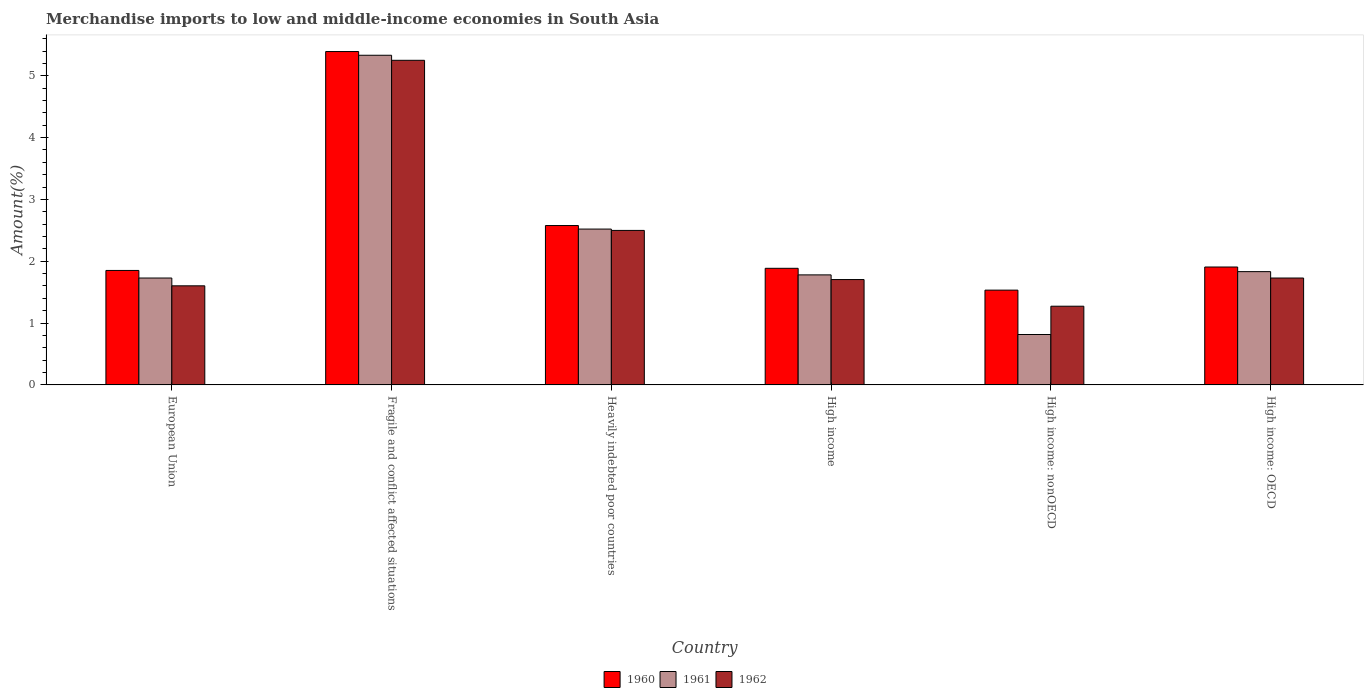How many groups of bars are there?
Your answer should be compact. 6. Are the number of bars per tick equal to the number of legend labels?
Your answer should be very brief. Yes. How many bars are there on the 6th tick from the right?
Make the answer very short. 3. What is the percentage of amount earned from merchandise imports in 1960 in High income: nonOECD?
Offer a very short reply. 1.53. Across all countries, what is the maximum percentage of amount earned from merchandise imports in 1960?
Your answer should be very brief. 5.39. Across all countries, what is the minimum percentage of amount earned from merchandise imports in 1960?
Ensure brevity in your answer.  1.53. In which country was the percentage of amount earned from merchandise imports in 1961 maximum?
Your answer should be very brief. Fragile and conflict affected situations. In which country was the percentage of amount earned from merchandise imports in 1962 minimum?
Provide a succinct answer. High income: nonOECD. What is the total percentage of amount earned from merchandise imports in 1961 in the graph?
Offer a very short reply. 14.01. What is the difference between the percentage of amount earned from merchandise imports in 1962 in Fragile and conflict affected situations and that in High income?
Give a very brief answer. 3.55. What is the difference between the percentage of amount earned from merchandise imports in 1960 in High income: nonOECD and the percentage of amount earned from merchandise imports in 1961 in European Union?
Offer a terse response. -0.2. What is the average percentage of amount earned from merchandise imports in 1961 per country?
Provide a succinct answer. 2.33. What is the difference between the percentage of amount earned from merchandise imports of/in 1962 and percentage of amount earned from merchandise imports of/in 1961 in European Union?
Provide a succinct answer. -0.13. In how many countries, is the percentage of amount earned from merchandise imports in 1962 greater than 5.2 %?
Provide a short and direct response. 1. What is the ratio of the percentage of amount earned from merchandise imports in 1962 in Fragile and conflict affected situations to that in High income: nonOECD?
Provide a short and direct response. 4.12. Is the percentage of amount earned from merchandise imports in 1960 in High income less than that in High income: nonOECD?
Keep it short and to the point. No. What is the difference between the highest and the second highest percentage of amount earned from merchandise imports in 1962?
Your answer should be compact. -0.77. What is the difference between the highest and the lowest percentage of amount earned from merchandise imports in 1961?
Offer a very short reply. 4.52. In how many countries, is the percentage of amount earned from merchandise imports in 1962 greater than the average percentage of amount earned from merchandise imports in 1962 taken over all countries?
Ensure brevity in your answer.  2. What does the 1st bar from the left in Fragile and conflict affected situations represents?
Ensure brevity in your answer.  1960. Is it the case that in every country, the sum of the percentage of amount earned from merchandise imports in 1961 and percentage of amount earned from merchandise imports in 1962 is greater than the percentage of amount earned from merchandise imports in 1960?
Keep it short and to the point. Yes. How many bars are there?
Your answer should be very brief. 18. Are all the bars in the graph horizontal?
Provide a short and direct response. No. How many countries are there in the graph?
Ensure brevity in your answer.  6. What is the difference between two consecutive major ticks on the Y-axis?
Offer a very short reply. 1. How many legend labels are there?
Your answer should be compact. 3. How are the legend labels stacked?
Your answer should be very brief. Horizontal. What is the title of the graph?
Your answer should be compact. Merchandise imports to low and middle-income economies in South Asia. What is the label or title of the X-axis?
Your response must be concise. Country. What is the label or title of the Y-axis?
Offer a terse response. Amount(%). What is the Amount(%) in 1960 in European Union?
Provide a succinct answer. 1.85. What is the Amount(%) in 1961 in European Union?
Offer a very short reply. 1.73. What is the Amount(%) of 1962 in European Union?
Provide a succinct answer. 1.6. What is the Amount(%) of 1960 in Fragile and conflict affected situations?
Your response must be concise. 5.39. What is the Amount(%) in 1961 in Fragile and conflict affected situations?
Provide a short and direct response. 5.33. What is the Amount(%) in 1962 in Fragile and conflict affected situations?
Ensure brevity in your answer.  5.25. What is the Amount(%) of 1960 in Heavily indebted poor countries?
Your response must be concise. 2.58. What is the Amount(%) in 1961 in Heavily indebted poor countries?
Your answer should be very brief. 2.52. What is the Amount(%) in 1962 in Heavily indebted poor countries?
Provide a succinct answer. 2.5. What is the Amount(%) of 1960 in High income?
Provide a succinct answer. 1.89. What is the Amount(%) of 1961 in High income?
Make the answer very short. 1.78. What is the Amount(%) of 1962 in High income?
Ensure brevity in your answer.  1.7. What is the Amount(%) of 1960 in High income: nonOECD?
Make the answer very short. 1.53. What is the Amount(%) in 1961 in High income: nonOECD?
Your answer should be very brief. 0.82. What is the Amount(%) in 1962 in High income: nonOECD?
Keep it short and to the point. 1.27. What is the Amount(%) of 1960 in High income: OECD?
Provide a short and direct response. 1.91. What is the Amount(%) in 1961 in High income: OECD?
Give a very brief answer. 1.83. What is the Amount(%) in 1962 in High income: OECD?
Offer a terse response. 1.73. Across all countries, what is the maximum Amount(%) in 1960?
Ensure brevity in your answer.  5.39. Across all countries, what is the maximum Amount(%) of 1961?
Offer a terse response. 5.33. Across all countries, what is the maximum Amount(%) in 1962?
Your response must be concise. 5.25. Across all countries, what is the minimum Amount(%) of 1960?
Offer a terse response. 1.53. Across all countries, what is the minimum Amount(%) in 1961?
Offer a very short reply. 0.82. Across all countries, what is the minimum Amount(%) of 1962?
Keep it short and to the point. 1.27. What is the total Amount(%) in 1960 in the graph?
Your answer should be very brief. 15.15. What is the total Amount(%) in 1961 in the graph?
Keep it short and to the point. 14.01. What is the total Amount(%) in 1962 in the graph?
Your response must be concise. 14.06. What is the difference between the Amount(%) of 1960 in European Union and that in Fragile and conflict affected situations?
Give a very brief answer. -3.54. What is the difference between the Amount(%) in 1961 in European Union and that in Fragile and conflict affected situations?
Provide a succinct answer. -3.6. What is the difference between the Amount(%) of 1962 in European Union and that in Fragile and conflict affected situations?
Give a very brief answer. -3.65. What is the difference between the Amount(%) of 1960 in European Union and that in Heavily indebted poor countries?
Keep it short and to the point. -0.73. What is the difference between the Amount(%) in 1961 in European Union and that in Heavily indebted poor countries?
Provide a succinct answer. -0.79. What is the difference between the Amount(%) in 1962 in European Union and that in Heavily indebted poor countries?
Make the answer very short. -0.9. What is the difference between the Amount(%) of 1960 in European Union and that in High income?
Your response must be concise. -0.03. What is the difference between the Amount(%) of 1961 in European Union and that in High income?
Offer a terse response. -0.05. What is the difference between the Amount(%) of 1962 in European Union and that in High income?
Offer a terse response. -0.1. What is the difference between the Amount(%) in 1960 in European Union and that in High income: nonOECD?
Keep it short and to the point. 0.32. What is the difference between the Amount(%) in 1961 in European Union and that in High income: nonOECD?
Your response must be concise. 0.91. What is the difference between the Amount(%) of 1962 in European Union and that in High income: nonOECD?
Keep it short and to the point. 0.33. What is the difference between the Amount(%) of 1960 in European Union and that in High income: OECD?
Provide a short and direct response. -0.06. What is the difference between the Amount(%) in 1961 in European Union and that in High income: OECD?
Provide a short and direct response. -0.1. What is the difference between the Amount(%) of 1962 in European Union and that in High income: OECD?
Your response must be concise. -0.13. What is the difference between the Amount(%) of 1960 in Fragile and conflict affected situations and that in Heavily indebted poor countries?
Your answer should be compact. 2.81. What is the difference between the Amount(%) of 1961 in Fragile and conflict affected situations and that in Heavily indebted poor countries?
Offer a very short reply. 2.81. What is the difference between the Amount(%) of 1962 in Fragile and conflict affected situations and that in Heavily indebted poor countries?
Ensure brevity in your answer.  2.75. What is the difference between the Amount(%) of 1960 in Fragile and conflict affected situations and that in High income?
Make the answer very short. 3.51. What is the difference between the Amount(%) of 1961 in Fragile and conflict affected situations and that in High income?
Your answer should be very brief. 3.55. What is the difference between the Amount(%) of 1962 in Fragile and conflict affected situations and that in High income?
Make the answer very short. 3.55. What is the difference between the Amount(%) of 1960 in Fragile and conflict affected situations and that in High income: nonOECD?
Provide a short and direct response. 3.86. What is the difference between the Amount(%) of 1961 in Fragile and conflict affected situations and that in High income: nonOECD?
Give a very brief answer. 4.52. What is the difference between the Amount(%) of 1962 in Fragile and conflict affected situations and that in High income: nonOECD?
Offer a very short reply. 3.98. What is the difference between the Amount(%) in 1960 in Fragile and conflict affected situations and that in High income: OECD?
Your answer should be compact. 3.49. What is the difference between the Amount(%) of 1961 in Fragile and conflict affected situations and that in High income: OECD?
Give a very brief answer. 3.5. What is the difference between the Amount(%) in 1962 in Fragile and conflict affected situations and that in High income: OECD?
Offer a very short reply. 3.52. What is the difference between the Amount(%) in 1960 in Heavily indebted poor countries and that in High income?
Provide a short and direct response. 0.69. What is the difference between the Amount(%) in 1961 in Heavily indebted poor countries and that in High income?
Your answer should be very brief. 0.74. What is the difference between the Amount(%) in 1962 in Heavily indebted poor countries and that in High income?
Offer a very short reply. 0.79. What is the difference between the Amount(%) in 1960 in Heavily indebted poor countries and that in High income: nonOECD?
Make the answer very short. 1.04. What is the difference between the Amount(%) in 1961 in Heavily indebted poor countries and that in High income: nonOECD?
Your answer should be very brief. 1.71. What is the difference between the Amount(%) in 1962 in Heavily indebted poor countries and that in High income: nonOECD?
Keep it short and to the point. 1.23. What is the difference between the Amount(%) in 1960 in Heavily indebted poor countries and that in High income: OECD?
Keep it short and to the point. 0.67. What is the difference between the Amount(%) in 1961 in Heavily indebted poor countries and that in High income: OECD?
Provide a succinct answer. 0.69. What is the difference between the Amount(%) of 1962 in Heavily indebted poor countries and that in High income: OECD?
Make the answer very short. 0.77. What is the difference between the Amount(%) of 1960 in High income and that in High income: nonOECD?
Provide a short and direct response. 0.35. What is the difference between the Amount(%) in 1961 in High income and that in High income: nonOECD?
Give a very brief answer. 0.96. What is the difference between the Amount(%) of 1962 in High income and that in High income: nonOECD?
Provide a short and direct response. 0.43. What is the difference between the Amount(%) in 1960 in High income and that in High income: OECD?
Keep it short and to the point. -0.02. What is the difference between the Amount(%) of 1961 in High income and that in High income: OECD?
Give a very brief answer. -0.05. What is the difference between the Amount(%) of 1962 in High income and that in High income: OECD?
Make the answer very short. -0.02. What is the difference between the Amount(%) in 1960 in High income: nonOECD and that in High income: OECD?
Provide a short and direct response. -0.37. What is the difference between the Amount(%) of 1961 in High income: nonOECD and that in High income: OECD?
Provide a short and direct response. -1.02. What is the difference between the Amount(%) of 1962 in High income: nonOECD and that in High income: OECD?
Ensure brevity in your answer.  -0.46. What is the difference between the Amount(%) in 1960 in European Union and the Amount(%) in 1961 in Fragile and conflict affected situations?
Make the answer very short. -3.48. What is the difference between the Amount(%) of 1960 in European Union and the Amount(%) of 1962 in Fragile and conflict affected situations?
Provide a short and direct response. -3.4. What is the difference between the Amount(%) of 1961 in European Union and the Amount(%) of 1962 in Fragile and conflict affected situations?
Make the answer very short. -3.52. What is the difference between the Amount(%) in 1960 in European Union and the Amount(%) in 1961 in Heavily indebted poor countries?
Provide a succinct answer. -0.67. What is the difference between the Amount(%) in 1960 in European Union and the Amount(%) in 1962 in Heavily indebted poor countries?
Offer a very short reply. -0.65. What is the difference between the Amount(%) in 1961 in European Union and the Amount(%) in 1962 in Heavily indebted poor countries?
Your response must be concise. -0.77. What is the difference between the Amount(%) of 1960 in European Union and the Amount(%) of 1961 in High income?
Ensure brevity in your answer.  0.07. What is the difference between the Amount(%) in 1960 in European Union and the Amount(%) in 1962 in High income?
Make the answer very short. 0.15. What is the difference between the Amount(%) in 1961 in European Union and the Amount(%) in 1962 in High income?
Offer a terse response. 0.02. What is the difference between the Amount(%) in 1960 in European Union and the Amount(%) in 1961 in High income: nonOECD?
Offer a very short reply. 1.04. What is the difference between the Amount(%) in 1960 in European Union and the Amount(%) in 1962 in High income: nonOECD?
Give a very brief answer. 0.58. What is the difference between the Amount(%) in 1961 in European Union and the Amount(%) in 1962 in High income: nonOECD?
Make the answer very short. 0.46. What is the difference between the Amount(%) of 1960 in European Union and the Amount(%) of 1961 in High income: OECD?
Give a very brief answer. 0.02. What is the difference between the Amount(%) in 1960 in European Union and the Amount(%) in 1962 in High income: OECD?
Your answer should be compact. 0.12. What is the difference between the Amount(%) of 1960 in Fragile and conflict affected situations and the Amount(%) of 1961 in Heavily indebted poor countries?
Make the answer very short. 2.87. What is the difference between the Amount(%) in 1960 in Fragile and conflict affected situations and the Amount(%) in 1962 in Heavily indebted poor countries?
Provide a short and direct response. 2.89. What is the difference between the Amount(%) of 1961 in Fragile and conflict affected situations and the Amount(%) of 1962 in Heavily indebted poor countries?
Offer a very short reply. 2.83. What is the difference between the Amount(%) of 1960 in Fragile and conflict affected situations and the Amount(%) of 1961 in High income?
Ensure brevity in your answer.  3.61. What is the difference between the Amount(%) in 1960 in Fragile and conflict affected situations and the Amount(%) in 1962 in High income?
Your answer should be very brief. 3.69. What is the difference between the Amount(%) of 1961 in Fragile and conflict affected situations and the Amount(%) of 1962 in High income?
Your answer should be compact. 3.63. What is the difference between the Amount(%) of 1960 in Fragile and conflict affected situations and the Amount(%) of 1961 in High income: nonOECD?
Your response must be concise. 4.58. What is the difference between the Amount(%) in 1960 in Fragile and conflict affected situations and the Amount(%) in 1962 in High income: nonOECD?
Give a very brief answer. 4.12. What is the difference between the Amount(%) in 1961 in Fragile and conflict affected situations and the Amount(%) in 1962 in High income: nonOECD?
Your response must be concise. 4.06. What is the difference between the Amount(%) in 1960 in Fragile and conflict affected situations and the Amount(%) in 1961 in High income: OECD?
Make the answer very short. 3.56. What is the difference between the Amount(%) in 1960 in Fragile and conflict affected situations and the Amount(%) in 1962 in High income: OECD?
Your answer should be compact. 3.66. What is the difference between the Amount(%) of 1961 in Fragile and conflict affected situations and the Amount(%) of 1962 in High income: OECD?
Make the answer very short. 3.6. What is the difference between the Amount(%) of 1960 in Heavily indebted poor countries and the Amount(%) of 1961 in High income?
Your answer should be very brief. 0.8. What is the difference between the Amount(%) in 1960 in Heavily indebted poor countries and the Amount(%) in 1962 in High income?
Provide a short and direct response. 0.87. What is the difference between the Amount(%) of 1961 in Heavily indebted poor countries and the Amount(%) of 1962 in High income?
Keep it short and to the point. 0.82. What is the difference between the Amount(%) in 1960 in Heavily indebted poor countries and the Amount(%) in 1961 in High income: nonOECD?
Offer a very short reply. 1.76. What is the difference between the Amount(%) of 1960 in Heavily indebted poor countries and the Amount(%) of 1962 in High income: nonOECD?
Offer a very short reply. 1.3. What is the difference between the Amount(%) of 1961 in Heavily indebted poor countries and the Amount(%) of 1962 in High income: nonOECD?
Your answer should be very brief. 1.25. What is the difference between the Amount(%) in 1960 in Heavily indebted poor countries and the Amount(%) in 1961 in High income: OECD?
Your response must be concise. 0.75. What is the difference between the Amount(%) of 1960 in Heavily indebted poor countries and the Amount(%) of 1962 in High income: OECD?
Keep it short and to the point. 0.85. What is the difference between the Amount(%) in 1961 in Heavily indebted poor countries and the Amount(%) in 1962 in High income: OECD?
Keep it short and to the point. 0.79. What is the difference between the Amount(%) of 1960 in High income and the Amount(%) of 1961 in High income: nonOECD?
Provide a succinct answer. 1.07. What is the difference between the Amount(%) of 1960 in High income and the Amount(%) of 1962 in High income: nonOECD?
Ensure brevity in your answer.  0.61. What is the difference between the Amount(%) in 1961 in High income and the Amount(%) in 1962 in High income: nonOECD?
Provide a succinct answer. 0.51. What is the difference between the Amount(%) in 1960 in High income and the Amount(%) in 1961 in High income: OECD?
Make the answer very short. 0.05. What is the difference between the Amount(%) in 1960 in High income and the Amount(%) in 1962 in High income: OECD?
Give a very brief answer. 0.16. What is the difference between the Amount(%) of 1961 in High income and the Amount(%) of 1962 in High income: OECD?
Provide a succinct answer. 0.05. What is the difference between the Amount(%) in 1960 in High income: nonOECD and the Amount(%) in 1961 in High income: OECD?
Offer a very short reply. -0.3. What is the difference between the Amount(%) of 1960 in High income: nonOECD and the Amount(%) of 1962 in High income: OECD?
Your answer should be very brief. -0.2. What is the difference between the Amount(%) in 1961 in High income: nonOECD and the Amount(%) in 1962 in High income: OECD?
Your answer should be very brief. -0.91. What is the average Amount(%) in 1960 per country?
Provide a short and direct response. 2.52. What is the average Amount(%) in 1961 per country?
Keep it short and to the point. 2.33. What is the average Amount(%) of 1962 per country?
Offer a very short reply. 2.34. What is the difference between the Amount(%) of 1960 and Amount(%) of 1961 in European Union?
Provide a succinct answer. 0.12. What is the difference between the Amount(%) in 1960 and Amount(%) in 1962 in European Union?
Your answer should be compact. 0.25. What is the difference between the Amount(%) of 1961 and Amount(%) of 1962 in European Union?
Give a very brief answer. 0.13. What is the difference between the Amount(%) in 1960 and Amount(%) in 1961 in Fragile and conflict affected situations?
Provide a short and direct response. 0.06. What is the difference between the Amount(%) of 1960 and Amount(%) of 1962 in Fragile and conflict affected situations?
Make the answer very short. 0.14. What is the difference between the Amount(%) of 1961 and Amount(%) of 1962 in Fragile and conflict affected situations?
Give a very brief answer. 0.08. What is the difference between the Amount(%) of 1960 and Amount(%) of 1961 in Heavily indebted poor countries?
Ensure brevity in your answer.  0.06. What is the difference between the Amount(%) in 1960 and Amount(%) in 1962 in Heavily indebted poor countries?
Give a very brief answer. 0.08. What is the difference between the Amount(%) of 1961 and Amount(%) of 1962 in Heavily indebted poor countries?
Offer a very short reply. 0.02. What is the difference between the Amount(%) of 1960 and Amount(%) of 1961 in High income?
Provide a short and direct response. 0.11. What is the difference between the Amount(%) of 1960 and Amount(%) of 1962 in High income?
Provide a succinct answer. 0.18. What is the difference between the Amount(%) of 1961 and Amount(%) of 1962 in High income?
Provide a succinct answer. 0.08. What is the difference between the Amount(%) of 1960 and Amount(%) of 1961 in High income: nonOECD?
Provide a succinct answer. 0.72. What is the difference between the Amount(%) of 1960 and Amount(%) of 1962 in High income: nonOECD?
Make the answer very short. 0.26. What is the difference between the Amount(%) in 1961 and Amount(%) in 1962 in High income: nonOECD?
Provide a short and direct response. -0.46. What is the difference between the Amount(%) in 1960 and Amount(%) in 1961 in High income: OECD?
Your answer should be compact. 0.07. What is the difference between the Amount(%) of 1960 and Amount(%) of 1962 in High income: OECD?
Provide a succinct answer. 0.18. What is the difference between the Amount(%) in 1961 and Amount(%) in 1962 in High income: OECD?
Give a very brief answer. 0.1. What is the ratio of the Amount(%) in 1960 in European Union to that in Fragile and conflict affected situations?
Your answer should be very brief. 0.34. What is the ratio of the Amount(%) in 1961 in European Union to that in Fragile and conflict affected situations?
Provide a short and direct response. 0.32. What is the ratio of the Amount(%) of 1962 in European Union to that in Fragile and conflict affected situations?
Offer a terse response. 0.31. What is the ratio of the Amount(%) of 1960 in European Union to that in Heavily indebted poor countries?
Provide a short and direct response. 0.72. What is the ratio of the Amount(%) in 1961 in European Union to that in Heavily indebted poor countries?
Your answer should be very brief. 0.69. What is the ratio of the Amount(%) in 1962 in European Union to that in Heavily indebted poor countries?
Your response must be concise. 0.64. What is the ratio of the Amount(%) of 1960 in European Union to that in High income?
Give a very brief answer. 0.98. What is the ratio of the Amount(%) in 1961 in European Union to that in High income?
Your answer should be very brief. 0.97. What is the ratio of the Amount(%) in 1962 in European Union to that in High income?
Make the answer very short. 0.94. What is the ratio of the Amount(%) in 1960 in European Union to that in High income: nonOECD?
Make the answer very short. 1.21. What is the ratio of the Amount(%) in 1961 in European Union to that in High income: nonOECD?
Keep it short and to the point. 2.12. What is the ratio of the Amount(%) of 1962 in European Union to that in High income: nonOECD?
Your answer should be very brief. 1.26. What is the ratio of the Amount(%) in 1960 in European Union to that in High income: OECD?
Keep it short and to the point. 0.97. What is the ratio of the Amount(%) in 1961 in European Union to that in High income: OECD?
Offer a terse response. 0.94. What is the ratio of the Amount(%) of 1962 in European Union to that in High income: OECD?
Provide a short and direct response. 0.93. What is the ratio of the Amount(%) of 1960 in Fragile and conflict affected situations to that in Heavily indebted poor countries?
Keep it short and to the point. 2.09. What is the ratio of the Amount(%) in 1961 in Fragile and conflict affected situations to that in Heavily indebted poor countries?
Keep it short and to the point. 2.12. What is the ratio of the Amount(%) in 1962 in Fragile and conflict affected situations to that in Heavily indebted poor countries?
Give a very brief answer. 2.1. What is the ratio of the Amount(%) of 1960 in Fragile and conflict affected situations to that in High income?
Your answer should be compact. 2.86. What is the ratio of the Amount(%) of 1961 in Fragile and conflict affected situations to that in High income?
Your answer should be very brief. 3. What is the ratio of the Amount(%) in 1962 in Fragile and conflict affected situations to that in High income?
Offer a terse response. 3.08. What is the ratio of the Amount(%) of 1960 in Fragile and conflict affected situations to that in High income: nonOECD?
Your answer should be very brief. 3.52. What is the ratio of the Amount(%) of 1961 in Fragile and conflict affected situations to that in High income: nonOECD?
Give a very brief answer. 6.54. What is the ratio of the Amount(%) in 1962 in Fragile and conflict affected situations to that in High income: nonOECD?
Offer a very short reply. 4.12. What is the ratio of the Amount(%) in 1960 in Fragile and conflict affected situations to that in High income: OECD?
Your response must be concise. 2.83. What is the ratio of the Amount(%) of 1961 in Fragile and conflict affected situations to that in High income: OECD?
Offer a very short reply. 2.91. What is the ratio of the Amount(%) of 1962 in Fragile and conflict affected situations to that in High income: OECD?
Your response must be concise. 3.04. What is the ratio of the Amount(%) of 1960 in Heavily indebted poor countries to that in High income?
Provide a short and direct response. 1.37. What is the ratio of the Amount(%) in 1961 in Heavily indebted poor countries to that in High income?
Offer a very short reply. 1.42. What is the ratio of the Amount(%) of 1962 in Heavily indebted poor countries to that in High income?
Provide a succinct answer. 1.47. What is the ratio of the Amount(%) of 1960 in Heavily indebted poor countries to that in High income: nonOECD?
Give a very brief answer. 1.68. What is the ratio of the Amount(%) in 1961 in Heavily indebted poor countries to that in High income: nonOECD?
Provide a short and direct response. 3.09. What is the ratio of the Amount(%) of 1962 in Heavily indebted poor countries to that in High income: nonOECD?
Your answer should be compact. 1.96. What is the ratio of the Amount(%) of 1960 in Heavily indebted poor countries to that in High income: OECD?
Give a very brief answer. 1.35. What is the ratio of the Amount(%) of 1961 in Heavily indebted poor countries to that in High income: OECD?
Your answer should be very brief. 1.38. What is the ratio of the Amount(%) in 1962 in Heavily indebted poor countries to that in High income: OECD?
Your response must be concise. 1.45. What is the ratio of the Amount(%) of 1960 in High income to that in High income: nonOECD?
Provide a succinct answer. 1.23. What is the ratio of the Amount(%) of 1961 in High income to that in High income: nonOECD?
Ensure brevity in your answer.  2.18. What is the ratio of the Amount(%) in 1962 in High income to that in High income: nonOECD?
Your response must be concise. 1.34. What is the ratio of the Amount(%) in 1960 in High income to that in High income: OECD?
Ensure brevity in your answer.  0.99. What is the ratio of the Amount(%) in 1961 in High income to that in High income: OECD?
Give a very brief answer. 0.97. What is the ratio of the Amount(%) of 1962 in High income to that in High income: OECD?
Your answer should be very brief. 0.99. What is the ratio of the Amount(%) in 1960 in High income: nonOECD to that in High income: OECD?
Keep it short and to the point. 0.8. What is the ratio of the Amount(%) in 1961 in High income: nonOECD to that in High income: OECD?
Give a very brief answer. 0.44. What is the ratio of the Amount(%) in 1962 in High income: nonOECD to that in High income: OECD?
Offer a very short reply. 0.74. What is the difference between the highest and the second highest Amount(%) of 1960?
Provide a succinct answer. 2.81. What is the difference between the highest and the second highest Amount(%) in 1961?
Ensure brevity in your answer.  2.81. What is the difference between the highest and the second highest Amount(%) in 1962?
Provide a succinct answer. 2.75. What is the difference between the highest and the lowest Amount(%) in 1960?
Your answer should be very brief. 3.86. What is the difference between the highest and the lowest Amount(%) of 1961?
Keep it short and to the point. 4.52. What is the difference between the highest and the lowest Amount(%) of 1962?
Offer a very short reply. 3.98. 